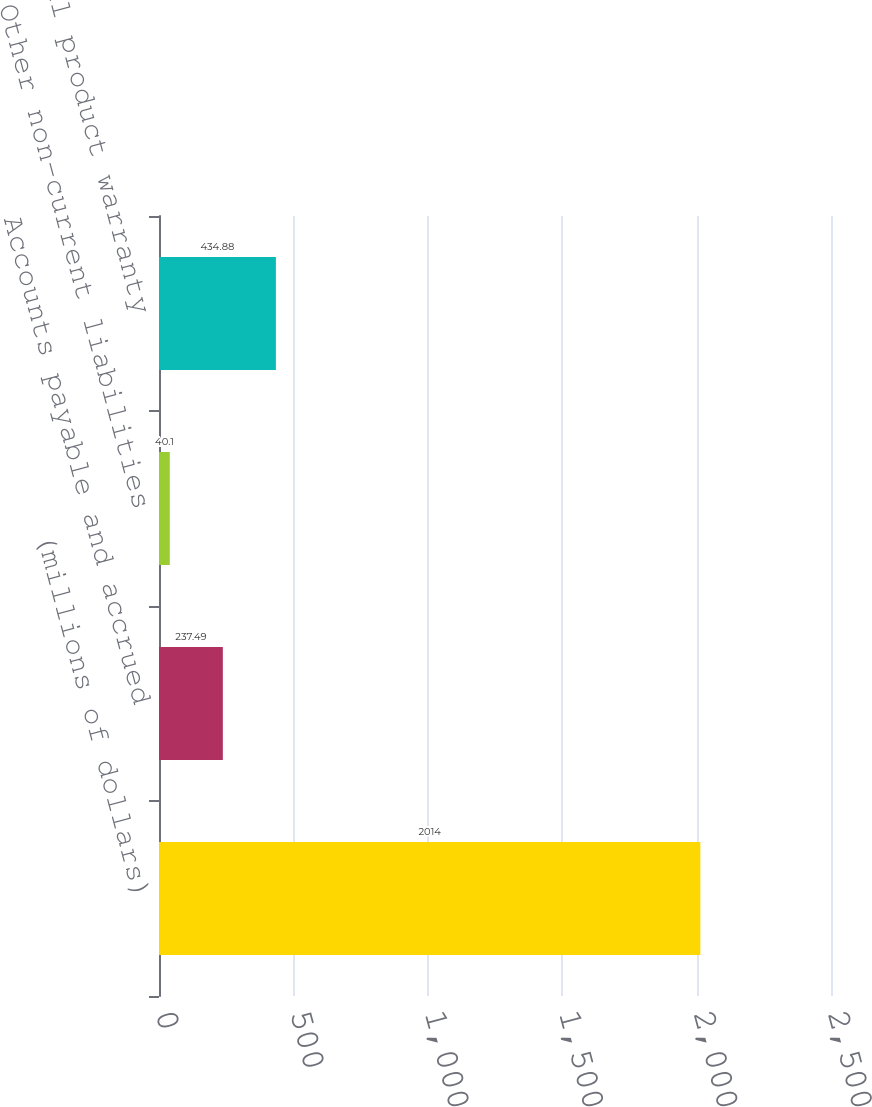Convert chart. <chart><loc_0><loc_0><loc_500><loc_500><bar_chart><fcel>(millions of dollars)<fcel>Accounts payable and accrued<fcel>Other non-current liabilities<fcel>Total product warranty<nl><fcel>2014<fcel>237.49<fcel>40.1<fcel>434.88<nl></chart> 